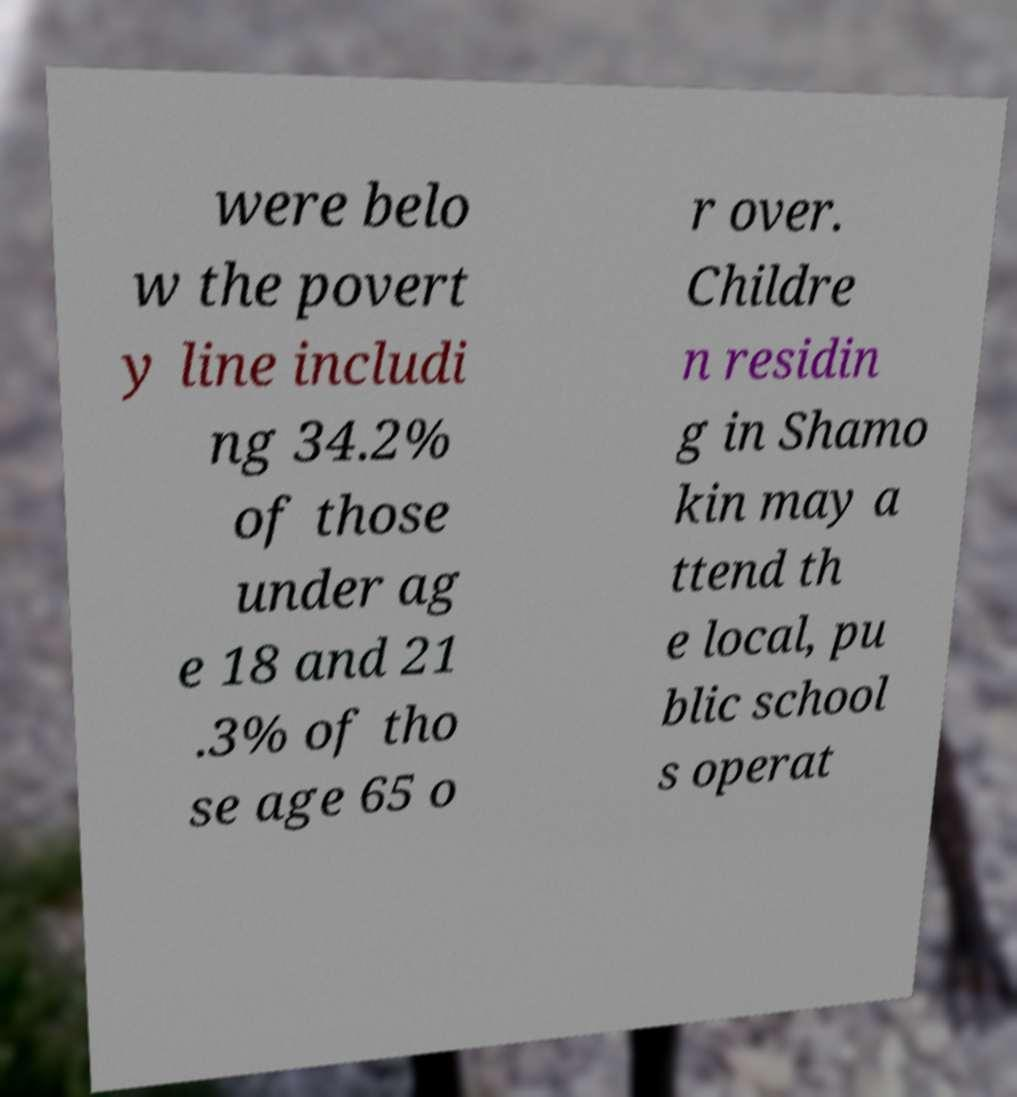There's text embedded in this image that I need extracted. Can you transcribe it verbatim? were belo w the povert y line includi ng 34.2% of those under ag e 18 and 21 .3% of tho se age 65 o r over. Childre n residin g in Shamo kin may a ttend th e local, pu blic school s operat 